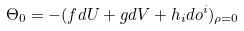Convert formula to latex. <formula><loc_0><loc_0><loc_500><loc_500>\Theta _ { 0 } = - ( f d U + g d V + h _ { i } d o ^ { i } ) _ { \rho = 0 }</formula> 